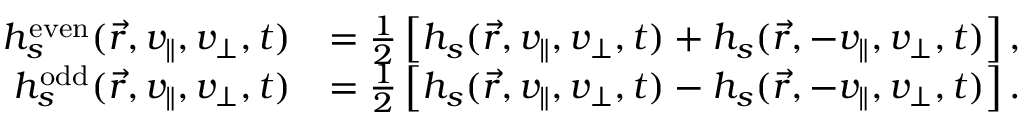Convert formula to latex. <formula><loc_0><loc_0><loc_500><loc_500>\begin{array} { r l } { h _ { s } ^ { e v e n } ( \vec { r } , v _ { \| } , v _ { \perp } , t ) } & { = \frac { 1 } { 2 } \left [ h _ { s } ( \vec { r } , v _ { \| } , v _ { \perp } , t ) + h _ { s } ( \vec { r } , - v _ { \| } , v _ { \perp } , t ) \right ] , } \\ { h _ { s } ^ { o d d } ( \vec { r } , v _ { \| } , v _ { \perp } , t ) } & { = \frac { 1 } { 2 } \left [ h _ { s } ( \vec { r } , v _ { \| } , v _ { \perp } , t ) - h _ { s } ( \vec { r } , - v _ { \| } , v _ { \perp } , t ) \right ] . } \end{array}</formula> 